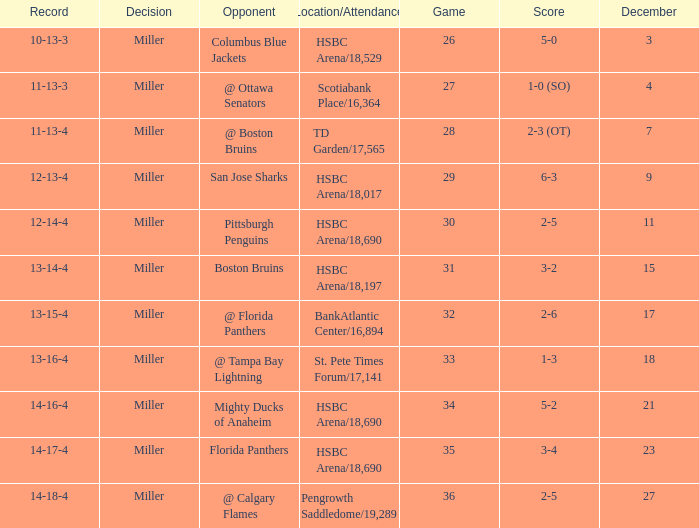Would you be able to parse every entry in this table? {'header': ['Record', 'Decision', 'Opponent', 'Location/Attendance', 'Game', 'Score', 'December'], 'rows': [['10-13-3', 'Miller', 'Columbus Blue Jackets', 'HSBC Arena/18,529', '26', '5-0', '3'], ['11-13-3', 'Miller', '@ Ottawa Senators', 'Scotiabank Place/16,364', '27', '1-0 (SO)', '4'], ['11-13-4', 'Miller', '@ Boston Bruins', 'TD Garden/17,565', '28', '2-3 (OT)', '7'], ['12-13-4', 'Miller', 'San Jose Sharks', 'HSBC Arena/18,017', '29', '6-3', '9'], ['12-14-4', 'Miller', 'Pittsburgh Penguins', 'HSBC Arena/18,690', '30', '2-5', '11'], ['13-14-4', 'Miller', 'Boston Bruins', 'HSBC Arena/18,197', '31', '3-2', '15'], ['13-15-4', 'Miller', '@ Florida Panthers', 'BankAtlantic Center/16,894', '32', '2-6', '17'], ['13-16-4', 'Miller', '@ Tampa Bay Lightning', 'St. Pete Times Forum/17,141', '33', '1-3', '18'], ['14-16-4', 'Miller', 'Mighty Ducks of Anaheim', 'HSBC Arena/18,690', '34', '5-2', '21'], ['14-17-4', 'Miller', 'Florida Panthers', 'HSBC Arena/18,690', '35', '3-4', '23'], ['14-18-4', 'Miller', '@ Calgary Flames', 'Pengrowth Saddledome/19,289', '36', '2-5', '27']]} Name the opponent for record 10-13-3 Columbus Blue Jackets. 